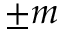Convert formula to latex. <formula><loc_0><loc_0><loc_500><loc_500>\pm m</formula> 